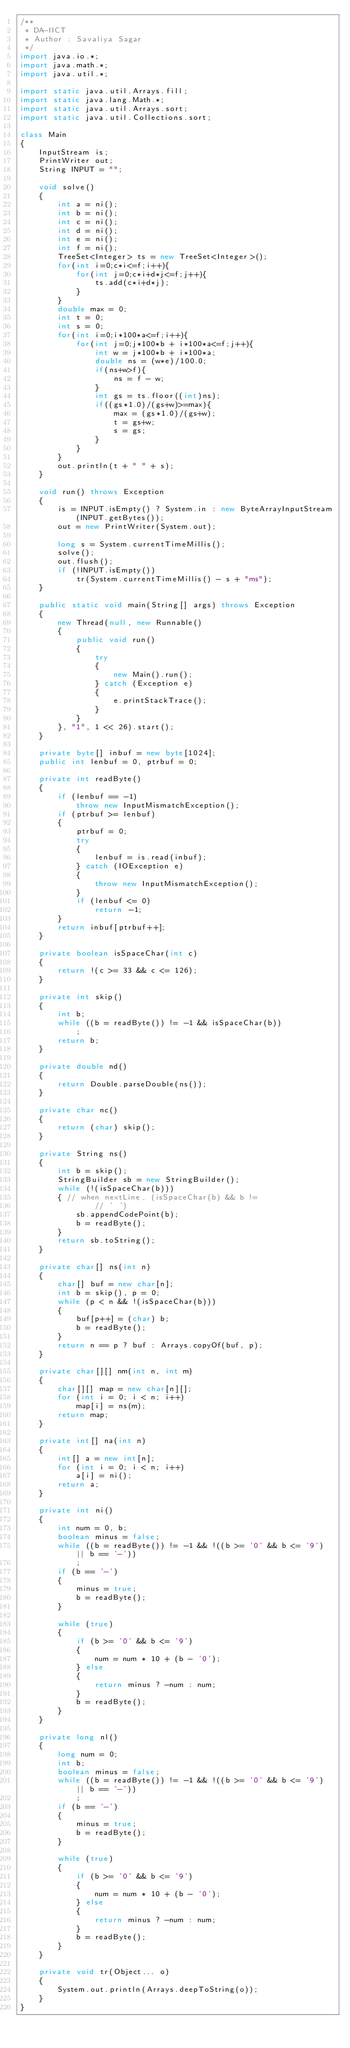<code> <loc_0><loc_0><loc_500><loc_500><_Java_>/**
 * DA-IICT
 * Author : Savaliya Sagar
 */
import java.io.*;
import java.math.*;
import java.util.*;

import static java.util.Arrays.fill;
import static java.lang.Math.*;
import static java.util.Arrays.sort;
import static java.util.Collections.sort;

class Main
{
	InputStream is;
	PrintWriter out;
	String INPUT = "";
	
	void solve()
	{
		int a = ni();
		int b = ni();
		int c = ni();
		int d = ni();
		int e = ni();
		int f = ni();
		TreeSet<Integer> ts = new TreeSet<Integer>();
		for(int i=0;c*i<=f;i++){
			for(int j=0;c*i+d*j<=f;j++){
				ts.add(c*i+d*j);
			}
		}
		double max = 0;
		int t = 0;
		int s = 0;
		for(int i=0;i*100*a<=f;i++){
			for(int j=0;j*100*b + i*100*a<=f;j++){
				int w = j*100*b + i*100*a;
				double ns = (w*e)/100.0;
				if(ns+w>f){
					ns = f - w;
				}
				int gs = ts.floor((int)ns);
				if((gs*1.0)/(gs+w)>=max){
					max = (gs*1.0)/(gs+w);
					t = gs+w;
					s = gs;
				}
			}
		}
		out.println(t + " " + s);
	}
	
	void run() throws Exception
	{
		is = INPUT.isEmpty() ? System.in : new ByteArrayInputStream(INPUT.getBytes());
		out = new PrintWriter(System.out);
		
		long s = System.currentTimeMillis();
		solve();
		out.flush();
		if (!INPUT.isEmpty())
			tr(System.currentTimeMillis() - s + "ms");
	}
	
	public static void main(String[] args) throws Exception
	{
		new Thread(null, new Runnable()
		{
			public void run()
			{
				try
				{
					new Main().run();
				} catch (Exception e)
				{
					e.printStackTrace();
				}
			}
		}, "1", 1 << 26).start();
	}
	
	private byte[] inbuf = new byte[1024];
	public int lenbuf = 0, ptrbuf = 0;
	
	private int readByte()
	{
		if (lenbuf == -1)
			throw new InputMismatchException();
		if (ptrbuf >= lenbuf)
		{
			ptrbuf = 0;
			try
			{
				lenbuf = is.read(inbuf);
			} catch (IOException e)
			{
				throw new InputMismatchException();
			}
			if (lenbuf <= 0)
				return -1;
		}
		return inbuf[ptrbuf++];
	}
	
	private boolean isSpaceChar(int c)
	{
		return !(c >= 33 && c <= 126);
	}
	
	private int skip()
	{
		int b;
		while ((b = readByte()) != -1 && isSpaceChar(b))
			;
		return b;
	}
	
	private double nd()
	{
		return Double.parseDouble(ns());
	}
	
	private char nc()
	{
		return (char) skip();
	}
	
	private String ns()
	{
		int b = skip();
		StringBuilder sb = new StringBuilder();
		while (!(isSpaceChar(b)))
		{ // when nextLine, (isSpaceChar(b) && b !=
				// ' ')
			sb.appendCodePoint(b);
			b = readByte();
		}
		return sb.toString();
	}
	
	private char[] ns(int n)
	{
		char[] buf = new char[n];
		int b = skip(), p = 0;
		while (p < n && !(isSpaceChar(b)))
		{
			buf[p++] = (char) b;
			b = readByte();
		}
		return n == p ? buf : Arrays.copyOf(buf, p);
	}
	
	private char[][] nm(int n, int m)
	{
		char[][] map = new char[n][];
		for (int i = 0; i < n; i++)
			map[i] = ns(m);
		return map;
	}
	
	private int[] na(int n)
	{
		int[] a = new int[n];
		for (int i = 0; i < n; i++)
			a[i] = ni();
		return a;
	}
	
	private int ni()
	{
		int num = 0, b;
		boolean minus = false;
		while ((b = readByte()) != -1 && !((b >= '0' && b <= '9') || b == '-'))
			;
		if (b == '-')
		{
			minus = true;
			b = readByte();
		}
		
		while (true)
		{
			if (b >= '0' && b <= '9')
			{
				num = num * 10 + (b - '0');
			} else
			{
				return minus ? -num : num;
			}
			b = readByte();
		}
	}
	
	private long nl()
	{
		long num = 0;
		int b;
		boolean minus = false;
		while ((b = readByte()) != -1 && !((b >= '0' && b <= '9') || b == '-'))
			;
		if (b == '-')
		{
			minus = true;
			b = readByte();
		}
		
		while (true)
		{
			if (b >= '0' && b <= '9')
			{
				num = num * 10 + (b - '0');
			} else
			{
				return minus ? -num : num;
			}
			b = readByte();
		}
	}
	
	private void tr(Object... o)
	{
		System.out.println(Arrays.deepToString(o));
	}
}
</code> 